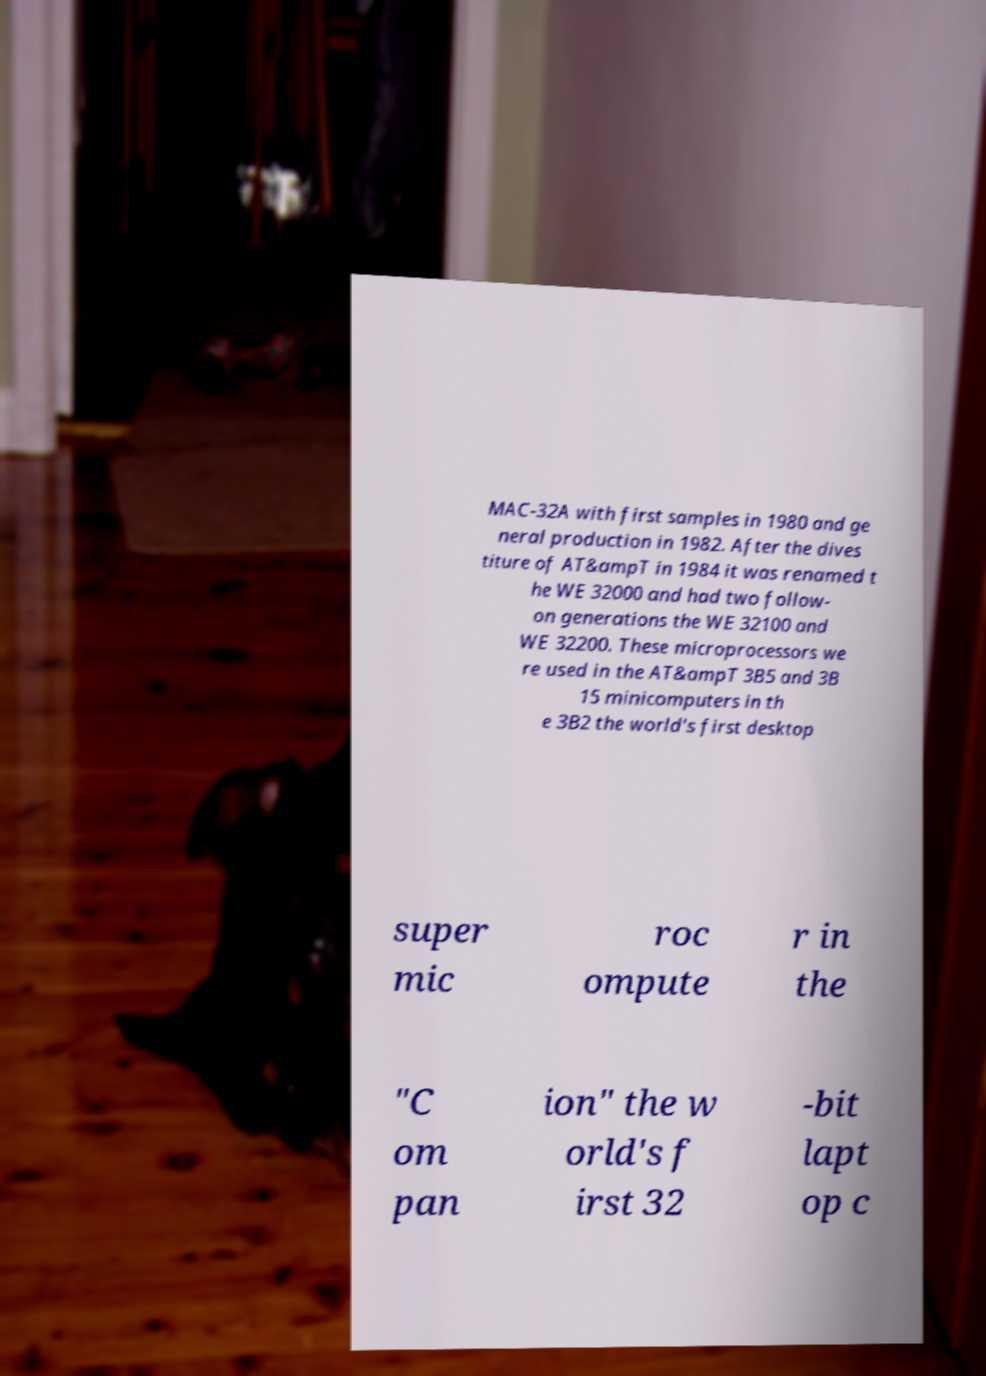Please identify and transcribe the text found in this image. MAC-32A with first samples in 1980 and ge neral production in 1982. After the dives titure of AT&ampT in 1984 it was renamed t he WE 32000 and had two follow- on generations the WE 32100 and WE 32200. These microprocessors we re used in the AT&ampT 3B5 and 3B 15 minicomputers in th e 3B2 the world's first desktop super mic roc ompute r in the "C om pan ion" the w orld's f irst 32 -bit lapt op c 